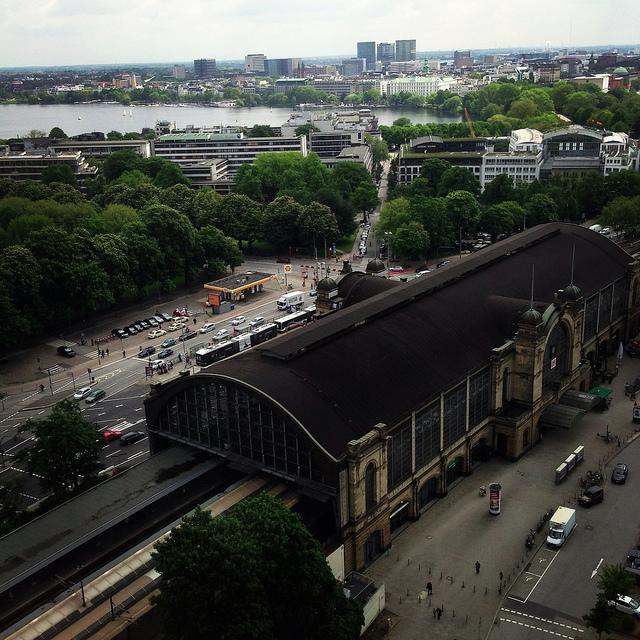The orange rimmed building probable sells which of these products? Please explain your reasoning. gas. This building is a gas station as cars can be seen filling up. 